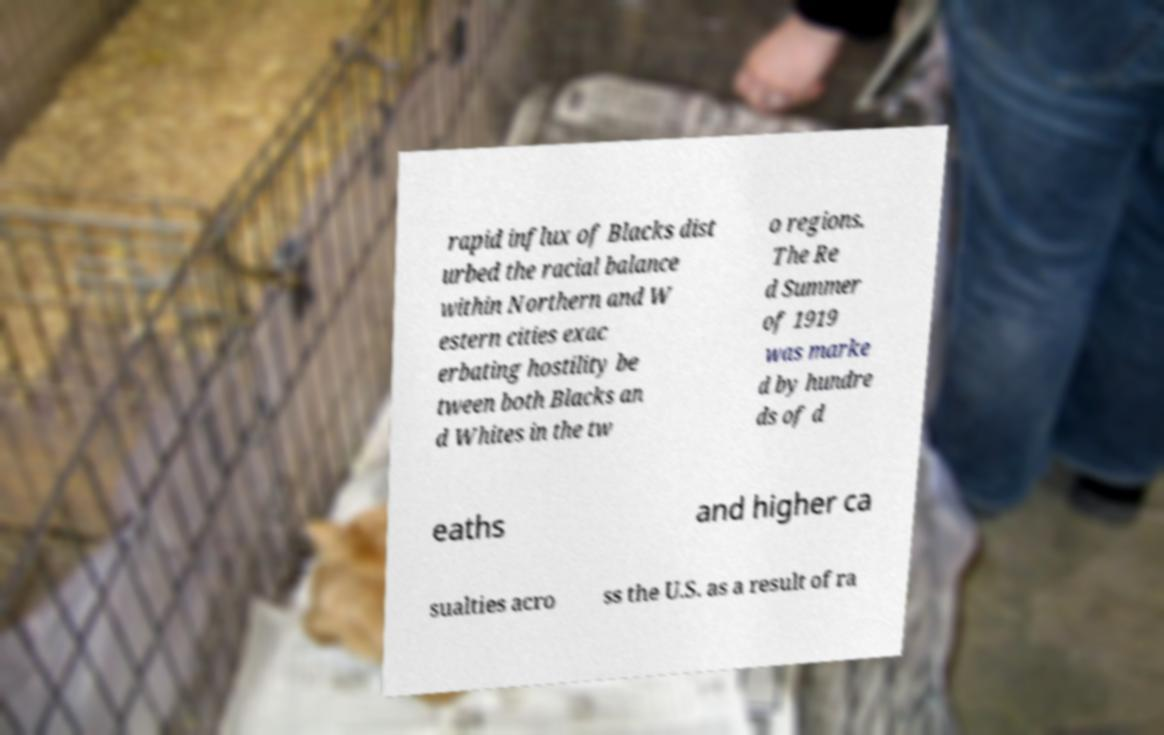I need the written content from this picture converted into text. Can you do that? rapid influx of Blacks dist urbed the racial balance within Northern and W estern cities exac erbating hostility be tween both Blacks an d Whites in the tw o regions. The Re d Summer of 1919 was marke d by hundre ds of d eaths and higher ca sualties acro ss the U.S. as a result of ra 